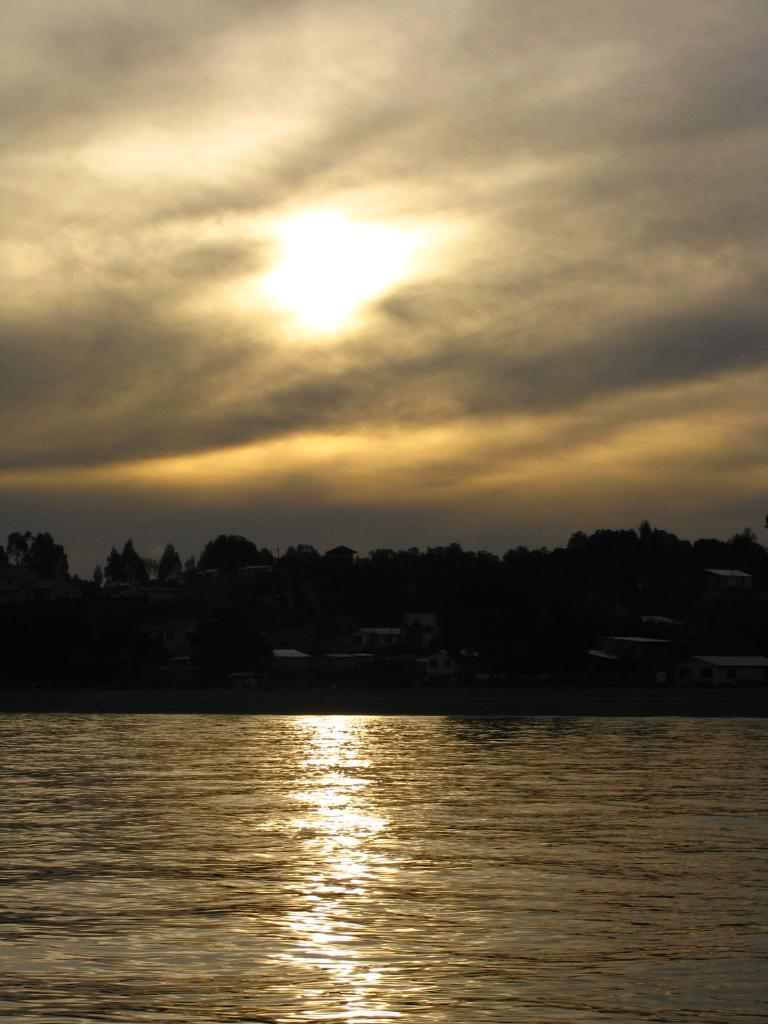What is in the front of the image? There is water in the front of the image. What can be seen in the background of the image? There are trees, buildings, clouds, and the sky visible in the background of the image. Can the sun be seen in the image? Yes, the sun is observable in the sky. What type of hill can be seen in the image? There is no hill present in the image. How much profit can be made from the water in the image? The image does not provide any information about making a profit from the water, as it is a visual representation and not a business scenario. 